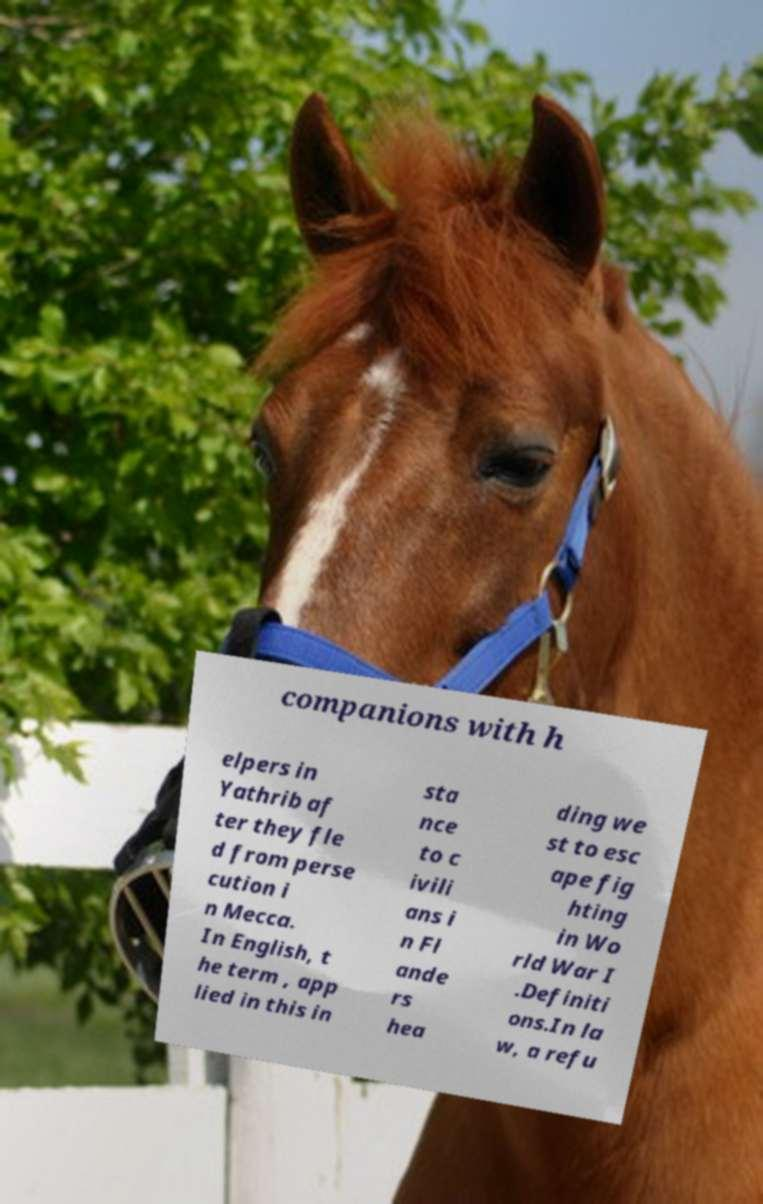Could you extract and type out the text from this image? companions with h elpers in Yathrib af ter they fle d from perse cution i n Mecca. In English, t he term , app lied in this in sta nce to c ivili ans i n Fl ande rs hea ding we st to esc ape fig hting in Wo rld War I .Definiti ons.In la w, a refu 